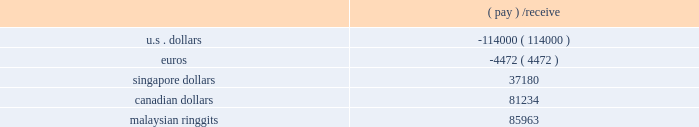Contracts as of december 31 , 2006 , which all mature in 2007 .
Forward contract notional amounts presented below are expressed in the stated currencies ( in thousands ) .
Forward currency contracts: .
A movement of 10% ( 10 % ) in the value of the u.s .
Dollar against foreign currencies would impact our expected net earnings by approximately $ 0.1 million .
Item 8 .
Financial statements and supplementary data the financial statements and supplementary data required by this item are included herein , commencing on page f-1 .
Item 9 .
Changes in and disagreements with accountants on accounting and financial disclosure item 9a .
Controls and procedures ( a ) evaluation of disclosure controls and procedures our management , with the participation of our chief executive officer and chief financial officer , evaluated the effectiveness of our disclosure controls and procedures as of the end of the period covered by this report .
Based on that evaluation , the chief executive officer and chief financial officer concluded that our disclosure controls and procedures as of the end of the period covered by this report are functioning effectively to provide reasonable assurance that the information required to be disclosed by us in reports filed under the securities exchange act of 1934 is ( i ) recorded , processed , summarized and reported within the time periods specified in the sec 2019s rules and forms and ( ii ) accumulated and communicated to our management , including the chief executive officer and chief financial officer , as appropriate to allow timely decisions regarding disclosure .
A controls system cannot provide absolute assurance , however , that the objectives of the controls system are met , and no evaluation of controls can provide absolute assurance that all control issues and instances of fraud , if any , within a company have been detected .
( b ) management 2019s report on internal control over financial reporting our management 2019s report on internal control over financial reporting is set forth on page f-2 of this annual report on form 10-k and is incorporated by reference herein .
( c ) change in internal control over financial reporting no change in our internal control over financial reporting occurred during our most recent fiscal quarter that has materially affected , or is reasonably likely to materially affect , our internal control over financial reporting .
Item 9b .
Other information .
What is a rough estimate of the ratio of securities given to securities received? 
Rationale: to find the ratio , one must add up the securities received by given . then one must divide the total securities received by the total securities given .
Computations: ((114000 + 4472) / (85963 + (37180 + 81234)))
Answer: 0.57967. 